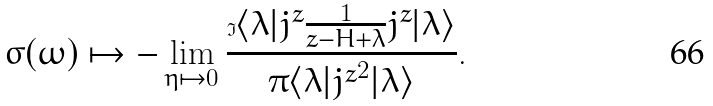Convert formula to latex. <formula><loc_0><loc_0><loc_500><loc_500>\sigma ( \omega ) \mapsto - \lim _ { \eta \mapsto 0 } \frac { \Im \langle \lambda | j ^ { z } \frac { 1 } { z - H + \lambda } j ^ { z } | \lambda \rangle } { \pi \langle \lambda | { j ^ { z } } ^ { 2 } | \lambda \rangle } .</formula> 